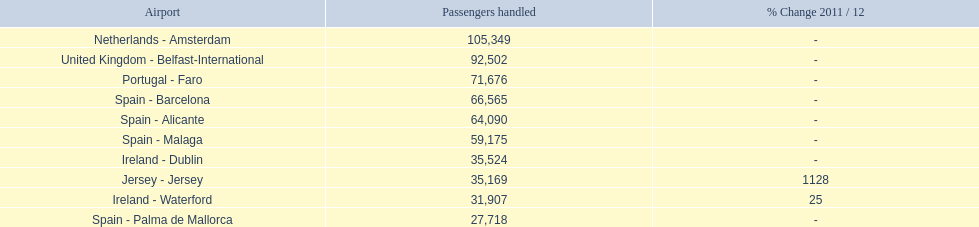How many airports can be found on the list? 10. 